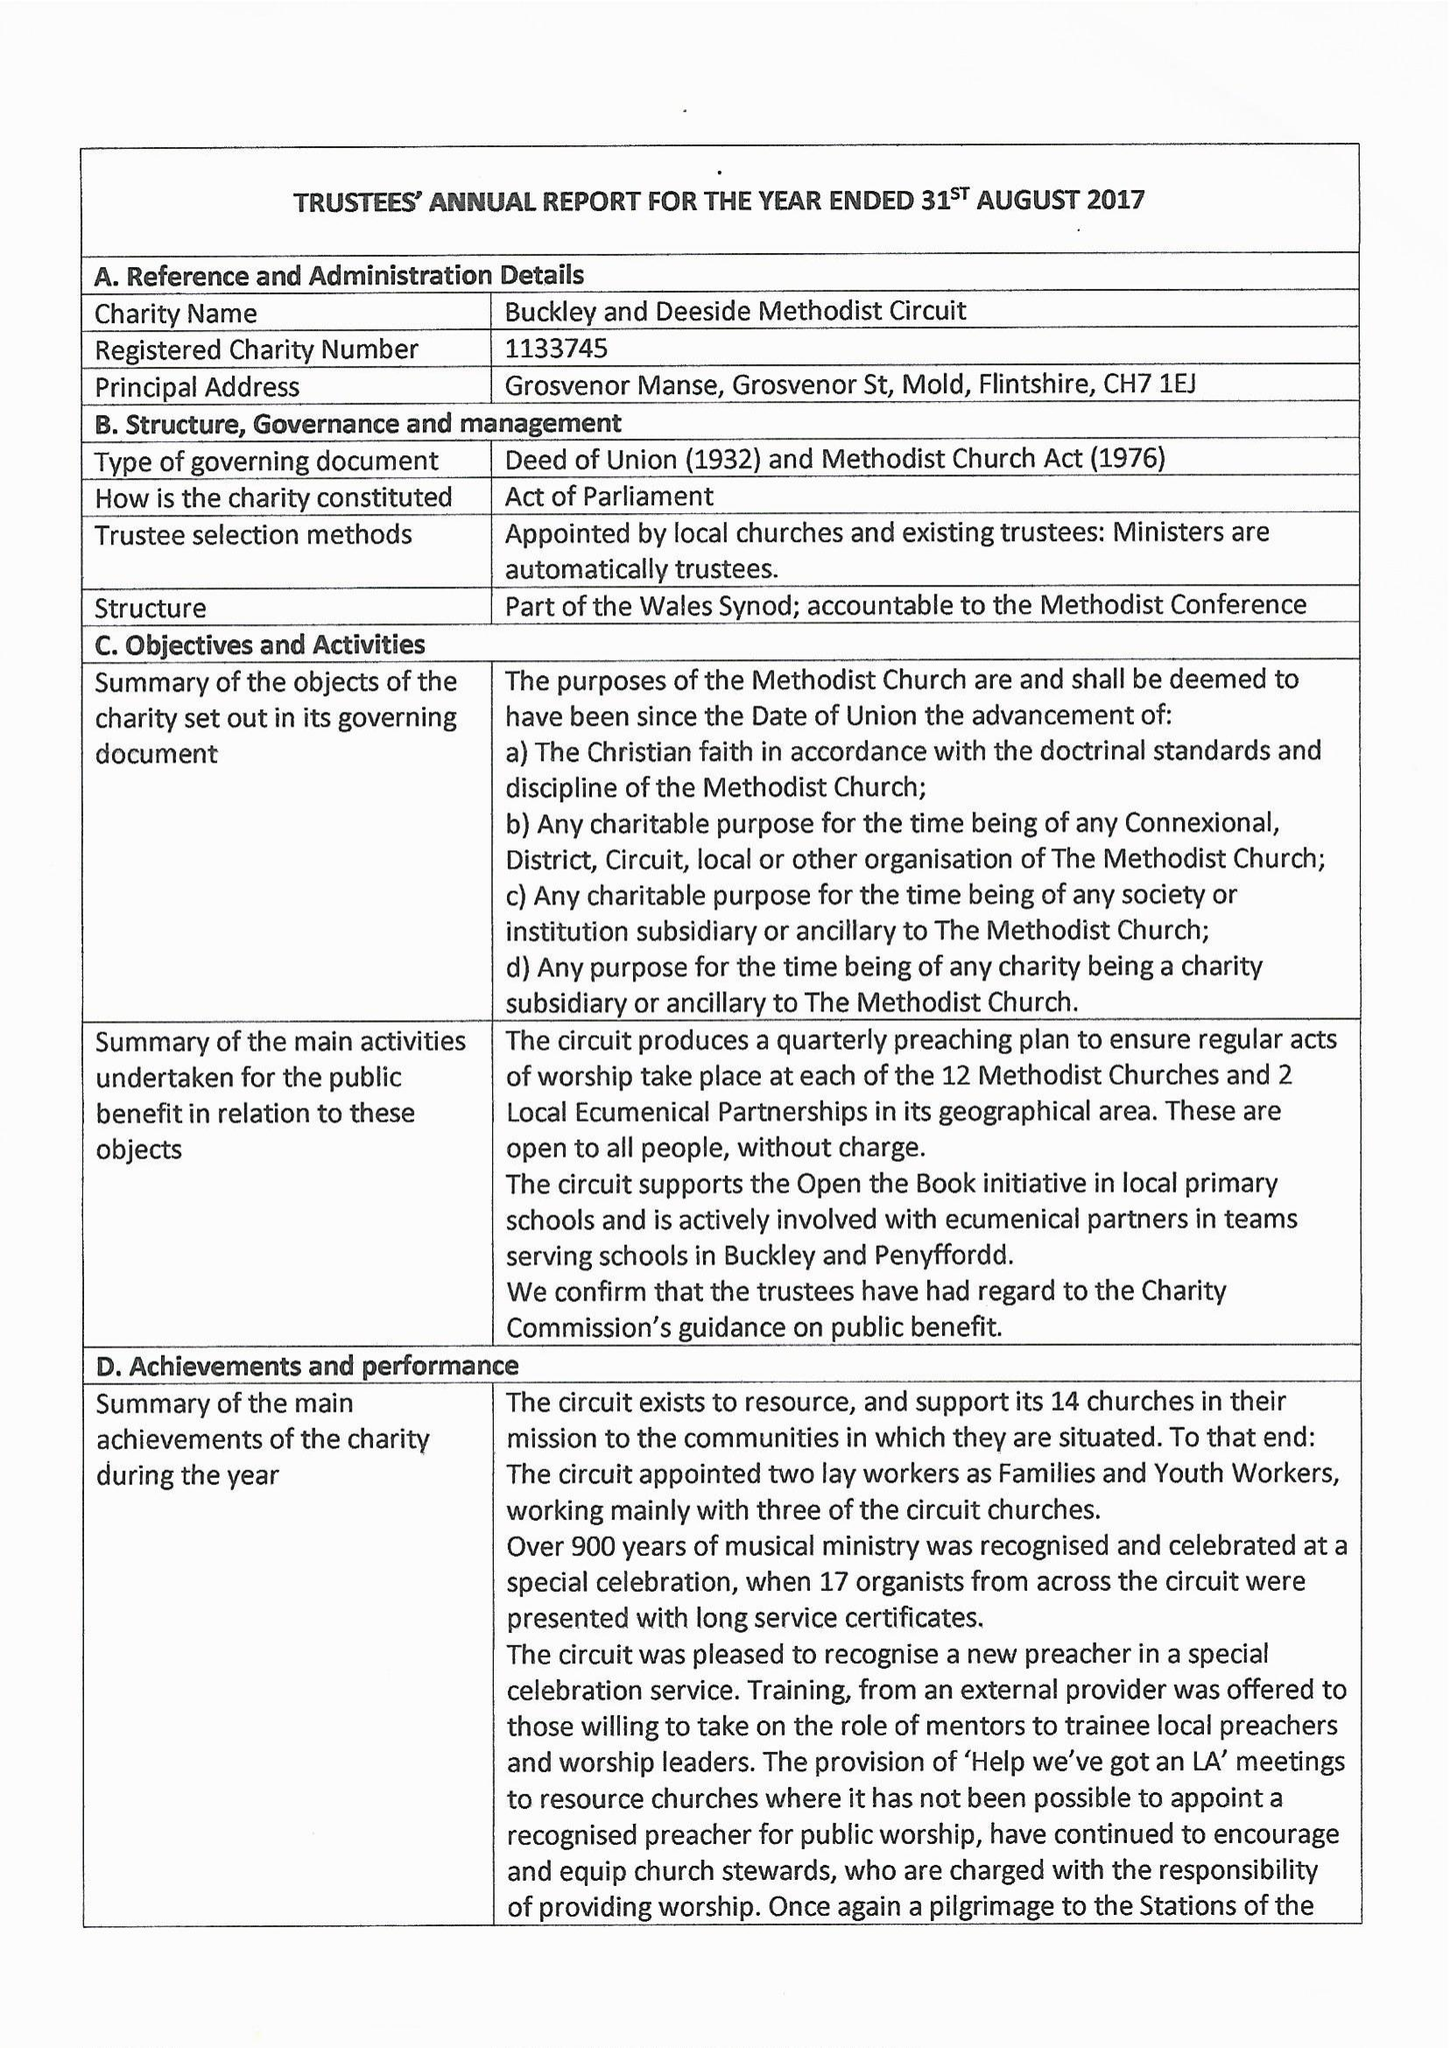What is the value for the address__street_line?
Answer the question using a single word or phrase. GROSVENOR STREET 